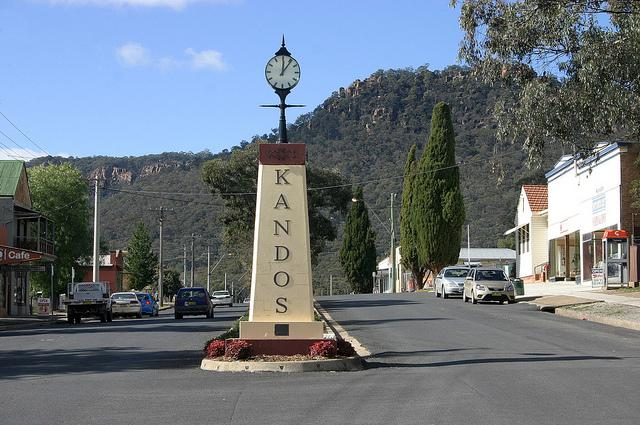What animal is native to this country? kangaroo 